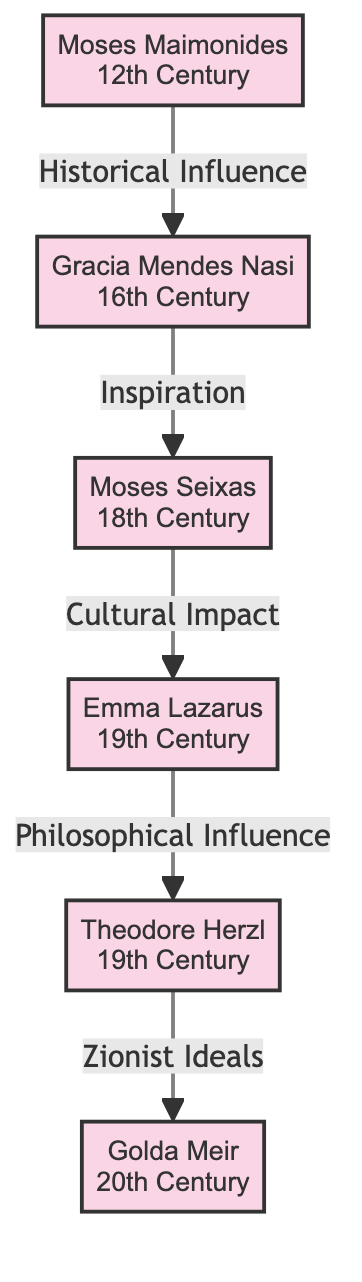What significant migration did Moses Maimonides undertake? Moses Maimonides migrated from Spain to Egypt, indicated in his title and description within the diagram.
Answer: From Spain to Egypt Who was influenced by Moses Maimonides? Gracia Mendes Nasi is directly connected to Moses Maimonides with a relationship described as "Historical Influence," highlighting that Maimonides had a significant impact on her.
Answer: Gracia Mendes Nasi How many edges are there in the diagram? By counting the lines connecting the nodes, there are five edges shown in the diagram, representing relationships between the figures.
Answer: 5 What type of relationship does Gracia Mendes Nasi have with Moses Seixas? The relationship from Gracia Mendes Nasi to Moses Seixas is labeled as "Inspiration," indicating she played an inspiring role in his journey or actions in migration.
Answer: Inspiration Which two figures are linked through "Zionist Ideals"? The figures linked through "Zionist Ideals" in the diagram are Theodore Herzl and Golda Meir, established by the directional edge from Herzl to Meir.
Answer: Theodore Herzl and Golda Meir What era does Emma Lazarus belong to? Emma Lazarus is noted in the diagram as belonging to the 19th Century, which is clearly indicated next to her name in the node.
Answer: 19th Century What is the influence of Emma Lazarus on Theodore Herzl? The influence is described as "Philosophical Influence," meaning that Lazarus significantly impacted Herzl's ideas or philosophies related to Jewish migration.
Answer: Philosophical Influence Who is the last figure in the chain of historical influences? The last figure in the chain of historical influences depicted in the diagram is Golda Meir, as no edges extend from her to any other figures, marking her as a concluding figure in this lineage.
Answer: Golda Meir What role did Moses Seixas play in the Jewish community? Moses Seixas is identified as a "Jewish community leader," showing his significance in establishing and leading a Jewish community in the United States.
Answer: Jewish community leader 